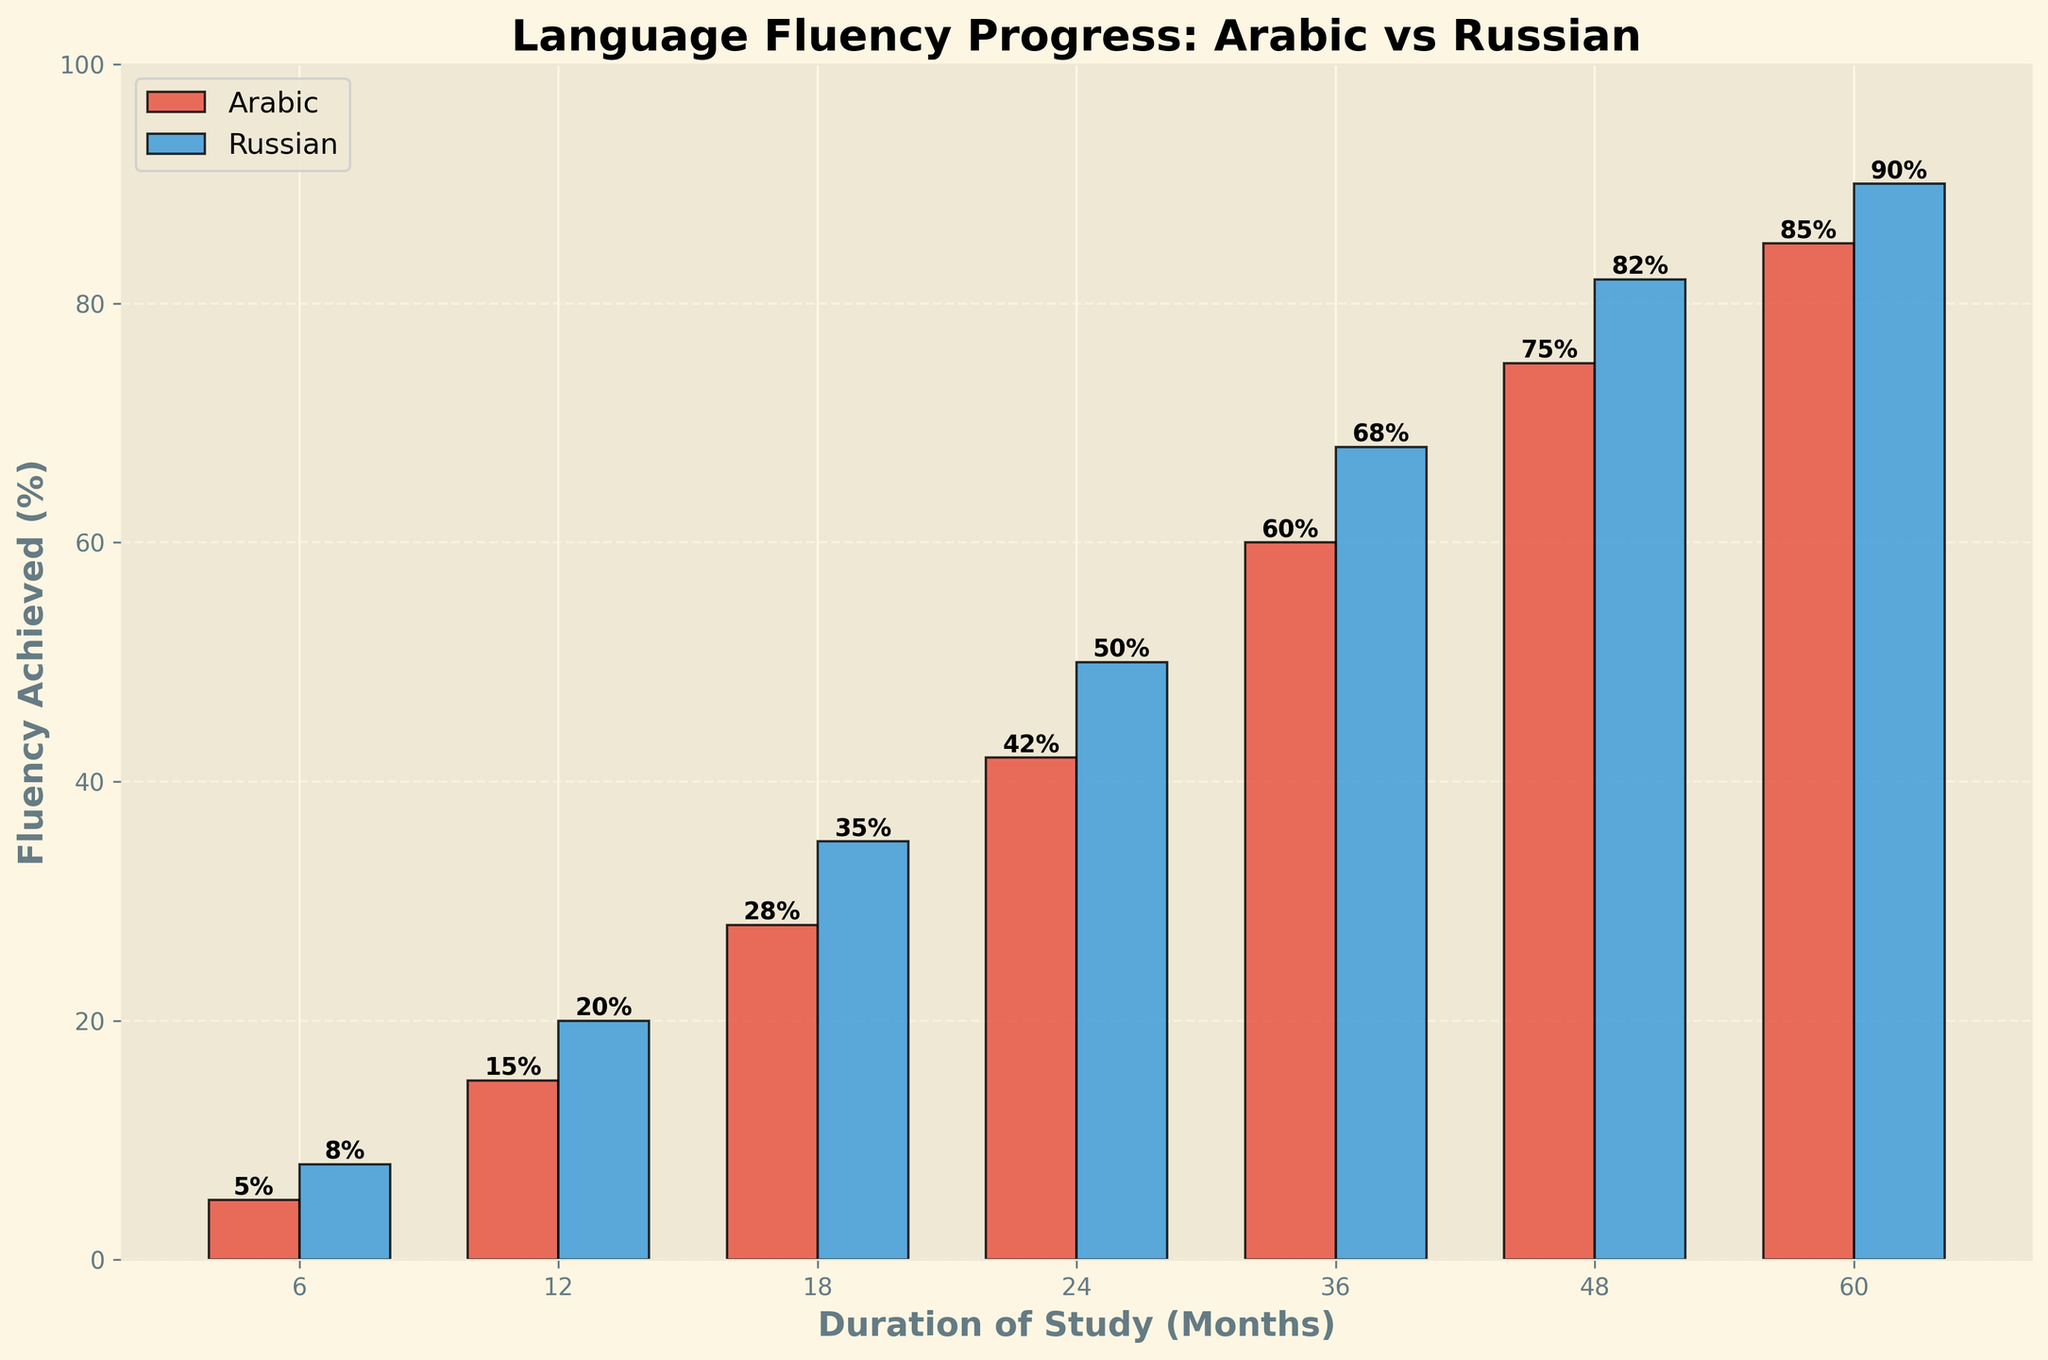What is the percentage of college students who achieve fluency in Arabic after 36 months of study? According to the figure, the bar representing Arabic fluency for 36 months of study reaches 60%.
Answer: 60% Which language has a higher fluency percentage after 12 months of study, Arabic or Russian? The fluency percentage for Arabic after 12 months is 15%, while for Russian it is 20%. Since 20% is greater than 15%, Russian has a higher fluency percentage.
Answer: Russian How many months of study are required for Arabic fluency to surpass 50%? By examining the bar heights closely, we find that Arabic fluency surpasses 50% at 36 months, where it reaches 60%.
Answer: 36 months What's the difference in fluency percentages between Arabic and Russian after 60 months of study? The fluency percentage for Arabic after 60 months is 85%, and for Russian, it is 90%. The difference is computed as 90% - 85%.
Answer: 5% Compare the fluency progress trend for both languages. After how many months does Russian fluency first exceed 50%? Checking the graph, Russian fluency exceeds 50% at 24 months, reaching 50%. Therefore, 24 is the first point at which Russian fluency exceeds 50%.
Answer: 24 months How much higher is Russian fluency compared to Arabic fluency after 18 months of study? Fluency for Russian after 18 months is 35%, while for Arabic it is 28%. The difference is calculated as 35% - 28%.
Answer: 7% What is the average fluency percentage of college students in Arabic across all durations? The fluency percentages for Arabic are [5, 15, 28, 42, 60, 75, 85]. Summing them gives us 310 and dividing by the number of durations (7), we find the average.
Answer: 44.3% What visual cue indicates the fluency level for Russian in the figure? The blue bars correspond to Russian fluency. Checking the height of the blue bars, we can assess the fluency levels.
Answer: Blue bars What is the total increase in Arabic fluency from 6 months to 60 months? The fluency for Arabic at 6 months is 5%, and at 60 months, it is 85%. The total increase is calculated as 85% - 5%.
Answer: 80% Is the growth in fluency over time more consistent for Arabic or Russian based on the figure? By looking at the figure, Russian fluency appears to be more consistent as its growth shows a more linear trend compared to the slightly varied growth trend for Arabic.
Answer: Russian 